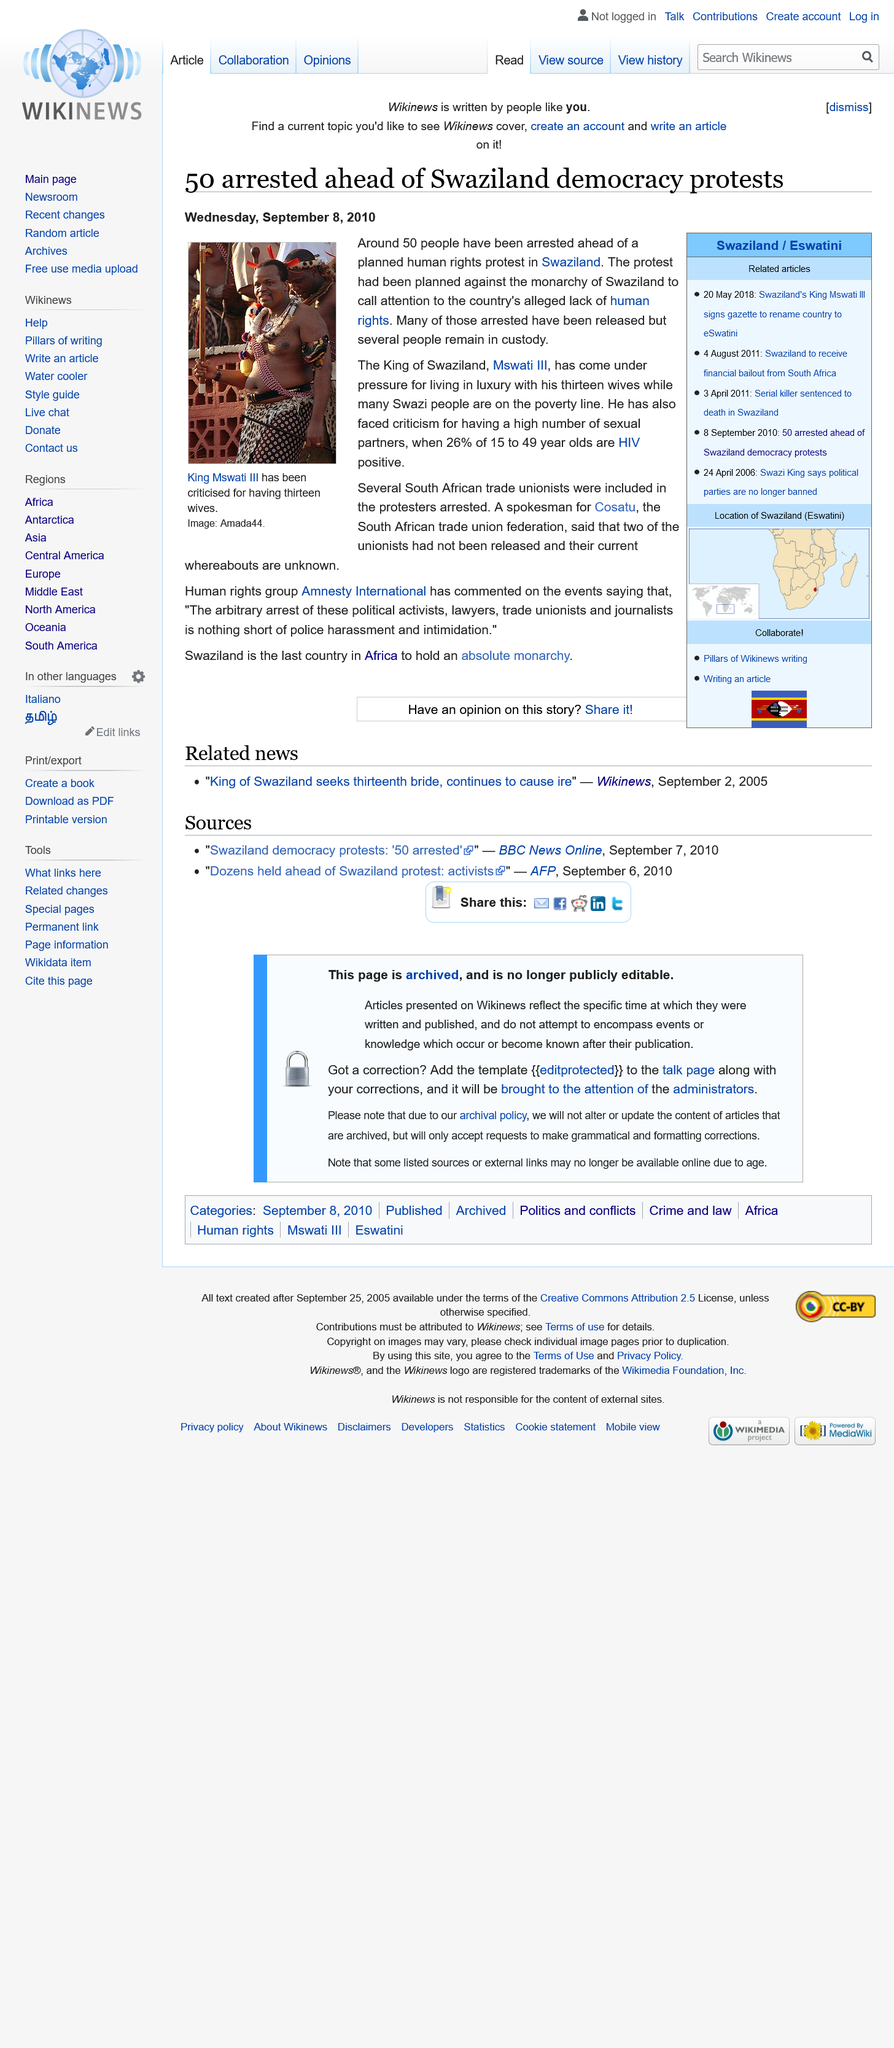Indicate a few pertinent items in this graphic. In Swaziland, approximately 26% of individuals aged 15 to 49 are HIV positive. Approximately 50 individuals were arrested for protesting against the human rights violations committed by the Swazi monarchy. King Mswati III of Swaziland has 13 wives. 